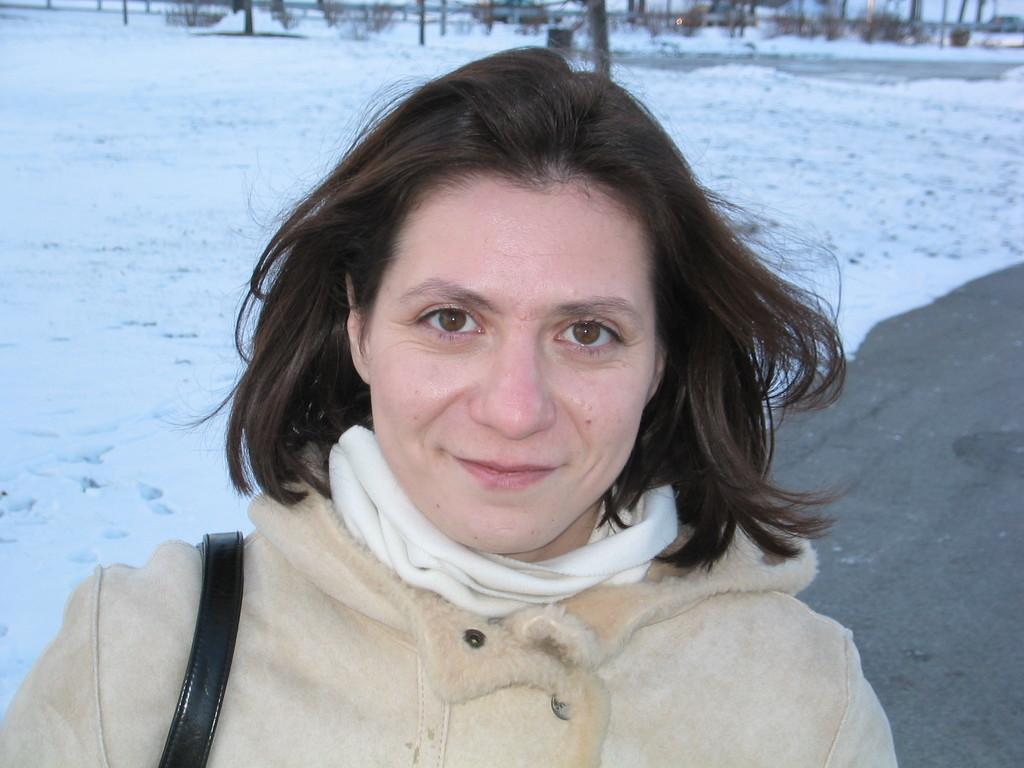Who is present in the image? There is a woman in the image. What is the woman's expression? The woman is smiling. What can be seen in the background of the image? There are wooden logs, snow, and a road in the background of the image. What type of toothbrush is the woman holding in the image? There is no toothbrush present in the image. What is the woman's opinion on the current political situation in the image? The image does not provide any information about the woman's opinion on the current political situation. 